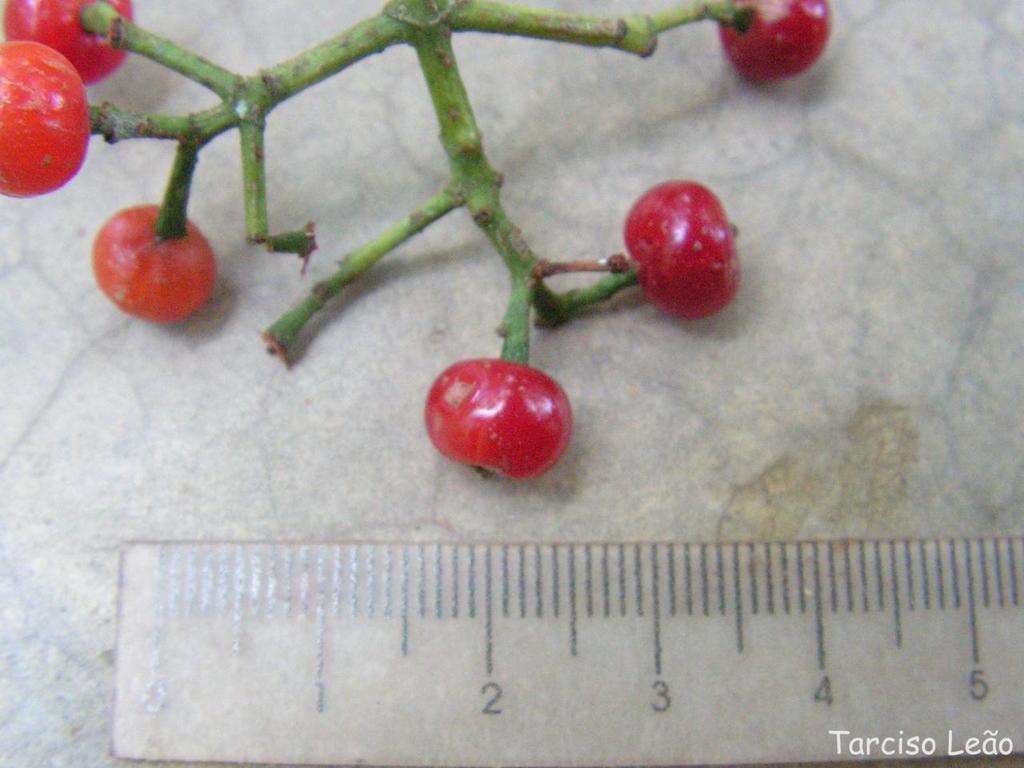What is the last number shown on the ruler?
Your answer should be compact. 5. Who is this photo credited to?
Give a very brief answer. Tarciso leao. 